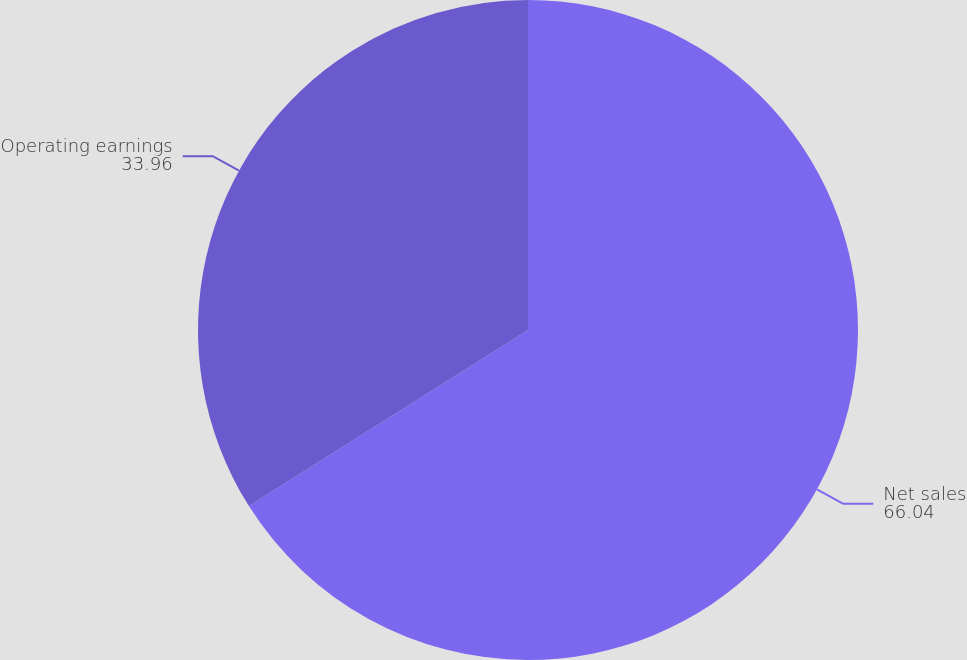<chart> <loc_0><loc_0><loc_500><loc_500><pie_chart><fcel>Net sales<fcel>Operating earnings<nl><fcel>66.04%<fcel>33.96%<nl></chart> 